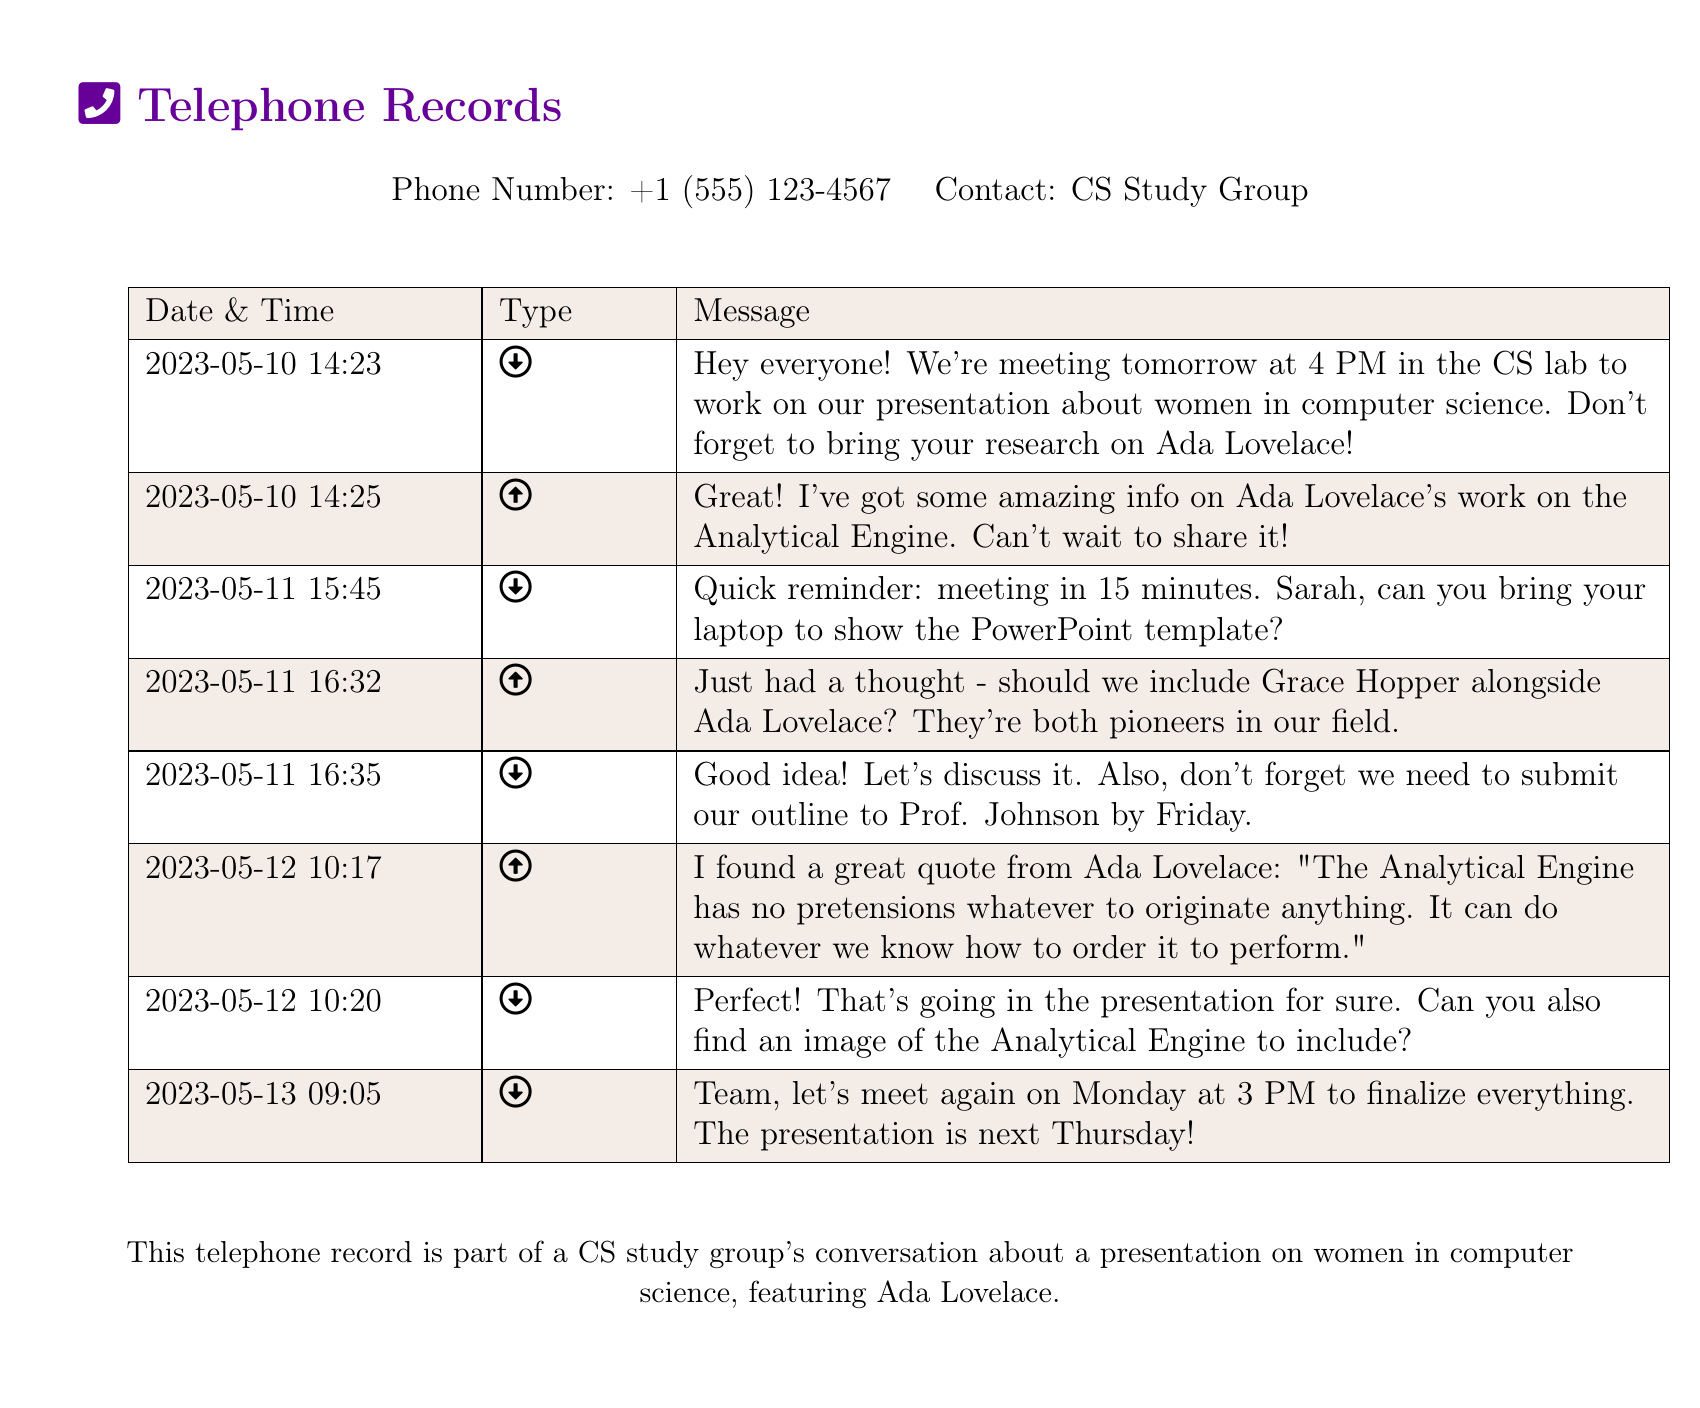What date is the meeting for the presentation? The meeting is scheduled for May 11, as indicated in the message.
Answer: May 11 What time is the final meeting scheduled? The final meeting is set for 3 PM on Monday, according to the last message.
Answer: 3 PM Who is mentioned alongside Ada Lovelace? Grace Hopper is mentioned as another pioneer in the field alongside Ada Lovelace.
Answer: Grace Hopper What does the quote from Ada Lovelace reference? The quote references the Analytical Engine and its capabilities, as noted in the message.
Answer: The Analytical Engine When is the outline due to Prof. Johnson? The outline needs to be submitted by Friday, as stated in the message.
Answer: Friday What topic is the presentation about? The presentation focuses on women in computer science, specifically mentioning Ada Lovelace.
Answer: Women in computer science Who is responsible for bringing the laptop? Sarah is asked to bring her laptop to show the PowerPoint template in the reminder message.
Answer: Sarah How long before the meeting was the quick reminder sent? The reminder was sent 15 minutes before the scheduled meeting time.
Answer: 15 minutes 